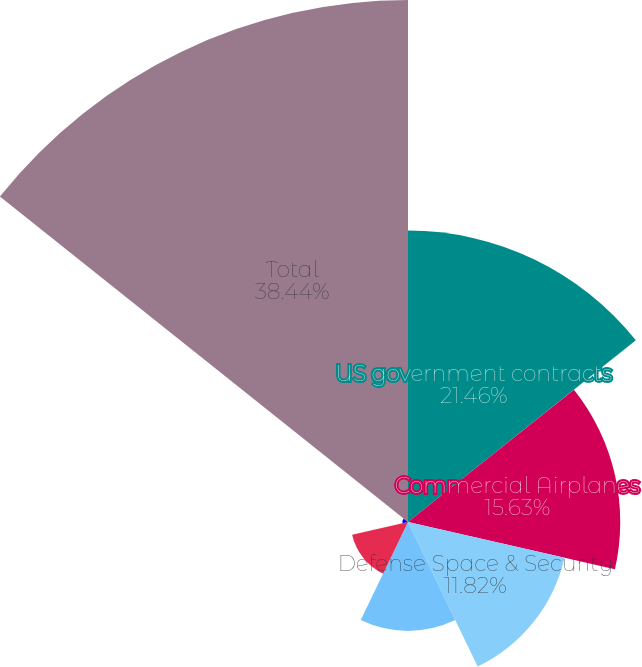Convert chart. <chart><loc_0><loc_0><loc_500><loc_500><pie_chart><fcel>US government contracts<fcel>Commercial Airplanes<fcel>Defense Space & Security<fcel>Reinsurance receivables<fcel>Other<fcel>Less valuation allowance<fcel>Total<nl><fcel>21.46%<fcel>15.63%<fcel>11.82%<fcel>8.02%<fcel>4.22%<fcel>0.41%<fcel>38.44%<nl></chart> 